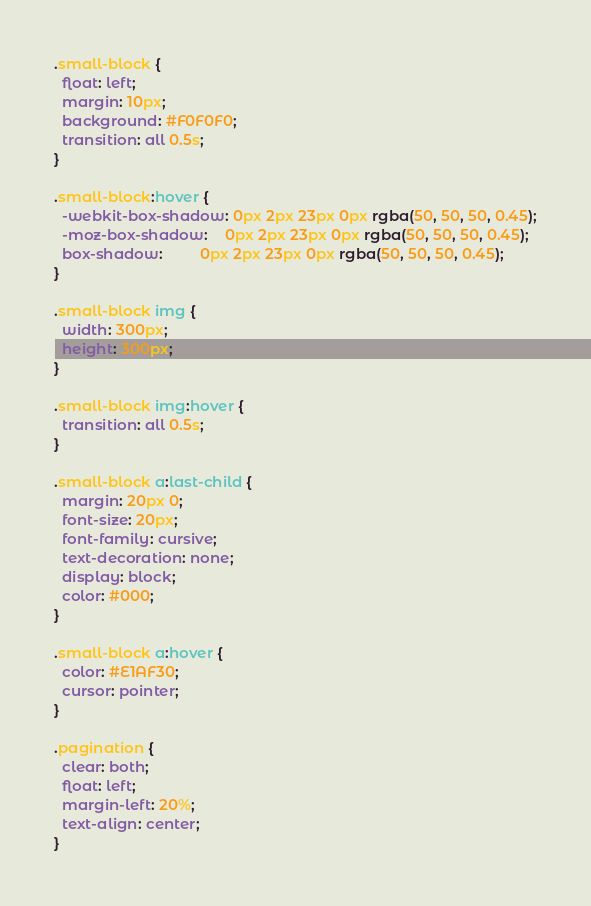Convert code to text. <code><loc_0><loc_0><loc_500><loc_500><_CSS_>
.small-block {
  float: left;
  margin: 10px;
  background: #F0F0F0;
  transition: all 0.5s;
}

.small-block:hover {
  -webkit-box-shadow: 0px 2px 23px 0px rgba(50, 50, 50, 0.45);
  -moz-box-shadow:    0px 2px 23px 0px rgba(50, 50, 50, 0.45);
  box-shadow:         0px 2px 23px 0px rgba(50, 50, 50, 0.45);
}

.small-block img {
  width: 300px;
  height: 300px;
}

.small-block img:hover {
  transition: all 0.5s;
}

.small-block a:last-child {
  margin: 20px 0;
  font-size: 20px;
  font-family: cursive;
  text-decoration: none;
  display: block;
  color: #000;
}

.small-block a:hover {
  color: #E1AF30;
  cursor: pointer;
}

.pagination {
  clear: both;
  float: left;
  margin-left: 20%;
  text-align: center;
}
</code> 